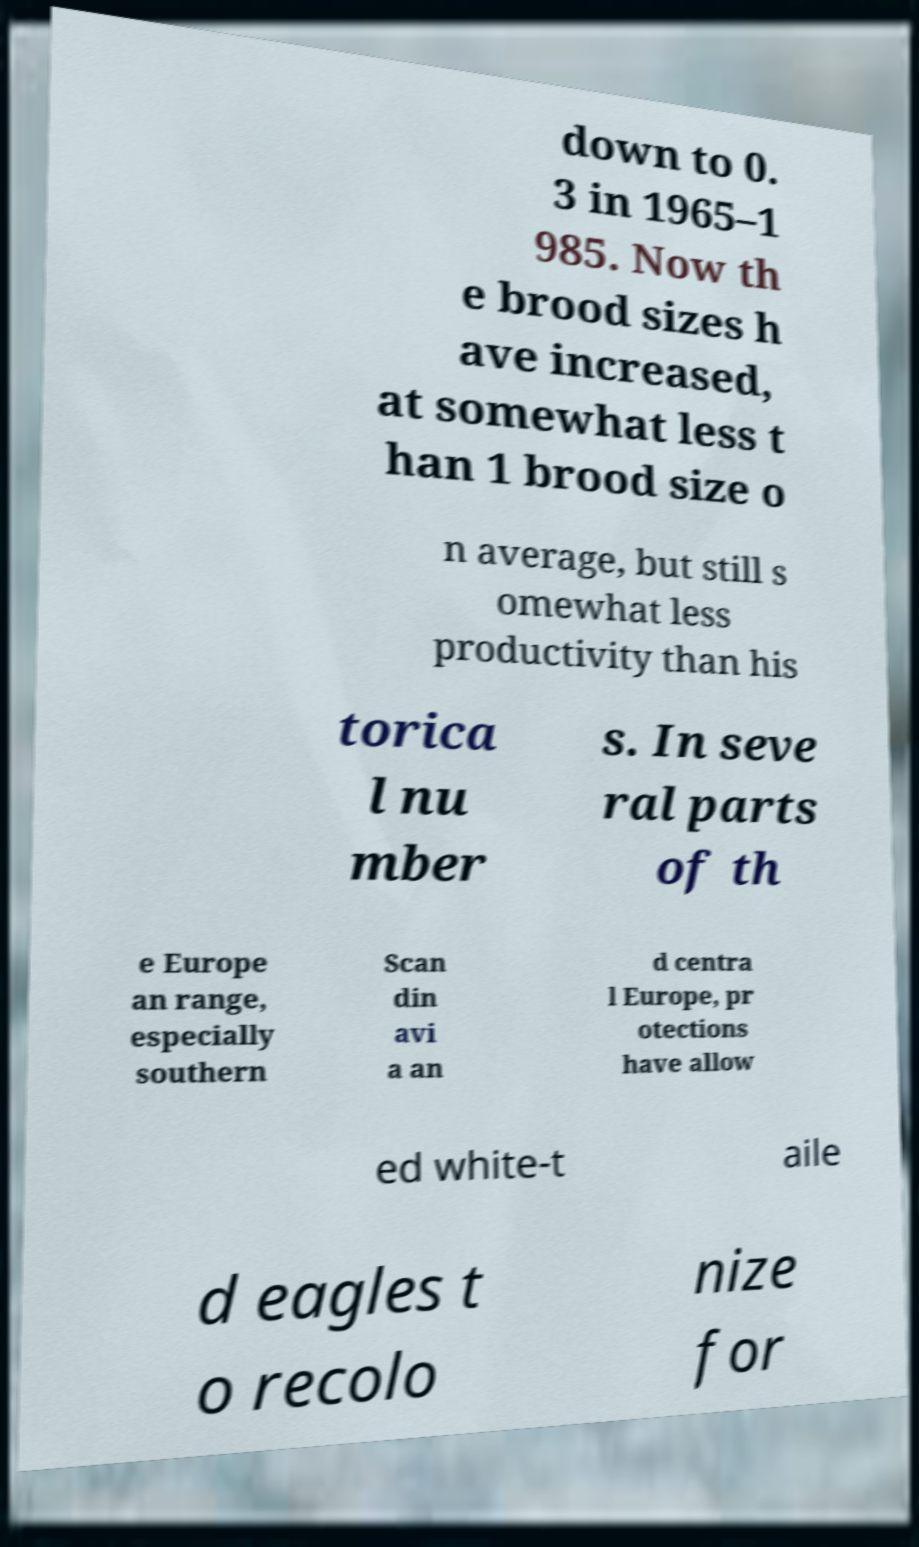Please identify and transcribe the text found in this image. down to 0. 3 in 1965–1 985. Now th e brood sizes h ave increased, at somewhat less t han 1 brood size o n average, but still s omewhat less productivity than his torica l nu mber s. In seve ral parts of th e Europe an range, especially southern Scan din avi a an d centra l Europe, pr otections have allow ed white-t aile d eagles t o recolo nize for 